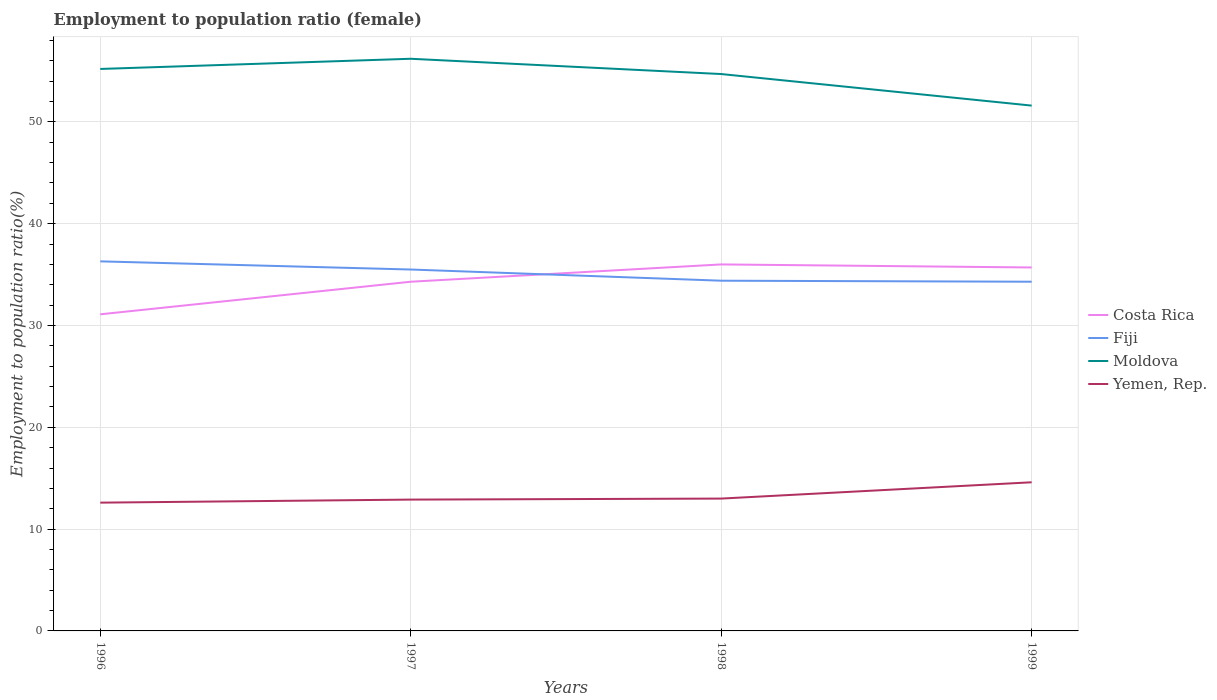How many different coloured lines are there?
Your answer should be compact. 4. Is the number of lines equal to the number of legend labels?
Ensure brevity in your answer.  Yes. Across all years, what is the maximum employment to population ratio in Moldova?
Your answer should be very brief. 51.6. What is the total employment to population ratio in Yemen, Rep. in the graph?
Keep it short and to the point. -1.7. Is the employment to population ratio in Yemen, Rep. strictly greater than the employment to population ratio in Costa Rica over the years?
Give a very brief answer. Yes. How many lines are there?
Offer a very short reply. 4. How many years are there in the graph?
Keep it short and to the point. 4. Does the graph contain grids?
Offer a terse response. Yes. What is the title of the graph?
Make the answer very short. Employment to population ratio (female). What is the label or title of the Y-axis?
Provide a succinct answer. Employment to population ratio(%). What is the Employment to population ratio(%) of Costa Rica in 1996?
Your answer should be very brief. 31.1. What is the Employment to population ratio(%) in Fiji in 1996?
Provide a succinct answer. 36.3. What is the Employment to population ratio(%) in Moldova in 1996?
Make the answer very short. 55.2. What is the Employment to population ratio(%) of Yemen, Rep. in 1996?
Ensure brevity in your answer.  12.6. What is the Employment to population ratio(%) in Costa Rica in 1997?
Ensure brevity in your answer.  34.3. What is the Employment to population ratio(%) in Fiji in 1997?
Your response must be concise. 35.5. What is the Employment to population ratio(%) in Moldova in 1997?
Keep it short and to the point. 56.2. What is the Employment to population ratio(%) in Yemen, Rep. in 1997?
Keep it short and to the point. 12.9. What is the Employment to population ratio(%) in Fiji in 1998?
Your response must be concise. 34.4. What is the Employment to population ratio(%) in Moldova in 1998?
Ensure brevity in your answer.  54.7. What is the Employment to population ratio(%) of Yemen, Rep. in 1998?
Give a very brief answer. 13. What is the Employment to population ratio(%) in Costa Rica in 1999?
Provide a short and direct response. 35.7. What is the Employment to population ratio(%) of Fiji in 1999?
Your answer should be compact. 34.3. What is the Employment to population ratio(%) of Moldova in 1999?
Provide a succinct answer. 51.6. What is the Employment to population ratio(%) of Yemen, Rep. in 1999?
Keep it short and to the point. 14.6. Across all years, what is the maximum Employment to population ratio(%) of Fiji?
Ensure brevity in your answer.  36.3. Across all years, what is the maximum Employment to population ratio(%) of Moldova?
Keep it short and to the point. 56.2. Across all years, what is the maximum Employment to population ratio(%) of Yemen, Rep.?
Offer a very short reply. 14.6. Across all years, what is the minimum Employment to population ratio(%) in Costa Rica?
Provide a succinct answer. 31.1. Across all years, what is the minimum Employment to population ratio(%) of Fiji?
Keep it short and to the point. 34.3. Across all years, what is the minimum Employment to population ratio(%) of Moldova?
Your answer should be compact. 51.6. Across all years, what is the minimum Employment to population ratio(%) of Yemen, Rep.?
Your answer should be compact. 12.6. What is the total Employment to population ratio(%) in Costa Rica in the graph?
Ensure brevity in your answer.  137.1. What is the total Employment to population ratio(%) of Fiji in the graph?
Your answer should be compact. 140.5. What is the total Employment to population ratio(%) in Moldova in the graph?
Give a very brief answer. 217.7. What is the total Employment to population ratio(%) in Yemen, Rep. in the graph?
Offer a terse response. 53.1. What is the difference between the Employment to population ratio(%) of Costa Rica in 1996 and that in 1997?
Provide a succinct answer. -3.2. What is the difference between the Employment to population ratio(%) in Fiji in 1996 and that in 1997?
Make the answer very short. 0.8. What is the difference between the Employment to population ratio(%) in Moldova in 1996 and that in 1997?
Your answer should be very brief. -1. What is the difference between the Employment to population ratio(%) in Fiji in 1996 and that in 1998?
Your answer should be very brief. 1.9. What is the difference between the Employment to population ratio(%) in Moldova in 1996 and that in 1998?
Provide a succinct answer. 0.5. What is the difference between the Employment to population ratio(%) of Yemen, Rep. in 1996 and that in 1998?
Your answer should be compact. -0.4. What is the difference between the Employment to population ratio(%) in Fiji in 1996 and that in 1999?
Make the answer very short. 2. What is the difference between the Employment to population ratio(%) of Fiji in 1997 and that in 1998?
Your answer should be very brief. 1.1. What is the difference between the Employment to population ratio(%) of Yemen, Rep. in 1997 and that in 1998?
Provide a succinct answer. -0.1. What is the difference between the Employment to population ratio(%) in Fiji in 1997 and that in 1999?
Ensure brevity in your answer.  1.2. What is the difference between the Employment to population ratio(%) in Moldova in 1997 and that in 1999?
Your answer should be compact. 4.6. What is the difference between the Employment to population ratio(%) in Costa Rica in 1998 and that in 1999?
Keep it short and to the point. 0.3. What is the difference between the Employment to population ratio(%) in Fiji in 1998 and that in 1999?
Provide a succinct answer. 0.1. What is the difference between the Employment to population ratio(%) in Moldova in 1998 and that in 1999?
Your answer should be compact. 3.1. What is the difference between the Employment to population ratio(%) in Costa Rica in 1996 and the Employment to population ratio(%) in Moldova in 1997?
Make the answer very short. -25.1. What is the difference between the Employment to population ratio(%) of Costa Rica in 1996 and the Employment to population ratio(%) of Yemen, Rep. in 1997?
Offer a very short reply. 18.2. What is the difference between the Employment to population ratio(%) in Fiji in 1996 and the Employment to population ratio(%) in Moldova in 1997?
Your response must be concise. -19.9. What is the difference between the Employment to population ratio(%) in Fiji in 1996 and the Employment to population ratio(%) in Yemen, Rep. in 1997?
Ensure brevity in your answer.  23.4. What is the difference between the Employment to population ratio(%) of Moldova in 1996 and the Employment to population ratio(%) of Yemen, Rep. in 1997?
Your answer should be compact. 42.3. What is the difference between the Employment to population ratio(%) in Costa Rica in 1996 and the Employment to population ratio(%) in Moldova in 1998?
Provide a succinct answer. -23.6. What is the difference between the Employment to population ratio(%) in Costa Rica in 1996 and the Employment to population ratio(%) in Yemen, Rep. in 1998?
Your answer should be very brief. 18.1. What is the difference between the Employment to population ratio(%) of Fiji in 1996 and the Employment to population ratio(%) of Moldova in 1998?
Offer a very short reply. -18.4. What is the difference between the Employment to population ratio(%) in Fiji in 1996 and the Employment to population ratio(%) in Yemen, Rep. in 1998?
Provide a succinct answer. 23.3. What is the difference between the Employment to population ratio(%) of Moldova in 1996 and the Employment to population ratio(%) of Yemen, Rep. in 1998?
Provide a short and direct response. 42.2. What is the difference between the Employment to population ratio(%) in Costa Rica in 1996 and the Employment to population ratio(%) in Fiji in 1999?
Provide a short and direct response. -3.2. What is the difference between the Employment to population ratio(%) in Costa Rica in 1996 and the Employment to population ratio(%) in Moldova in 1999?
Ensure brevity in your answer.  -20.5. What is the difference between the Employment to population ratio(%) in Fiji in 1996 and the Employment to population ratio(%) in Moldova in 1999?
Ensure brevity in your answer.  -15.3. What is the difference between the Employment to population ratio(%) of Fiji in 1996 and the Employment to population ratio(%) of Yemen, Rep. in 1999?
Ensure brevity in your answer.  21.7. What is the difference between the Employment to population ratio(%) in Moldova in 1996 and the Employment to population ratio(%) in Yemen, Rep. in 1999?
Ensure brevity in your answer.  40.6. What is the difference between the Employment to population ratio(%) of Costa Rica in 1997 and the Employment to population ratio(%) of Moldova in 1998?
Give a very brief answer. -20.4. What is the difference between the Employment to population ratio(%) of Costa Rica in 1997 and the Employment to population ratio(%) of Yemen, Rep. in 1998?
Provide a succinct answer. 21.3. What is the difference between the Employment to population ratio(%) in Fiji in 1997 and the Employment to population ratio(%) in Moldova in 1998?
Ensure brevity in your answer.  -19.2. What is the difference between the Employment to population ratio(%) of Moldova in 1997 and the Employment to population ratio(%) of Yemen, Rep. in 1998?
Offer a terse response. 43.2. What is the difference between the Employment to population ratio(%) of Costa Rica in 1997 and the Employment to population ratio(%) of Fiji in 1999?
Your answer should be very brief. 0. What is the difference between the Employment to population ratio(%) of Costa Rica in 1997 and the Employment to population ratio(%) of Moldova in 1999?
Your answer should be very brief. -17.3. What is the difference between the Employment to population ratio(%) of Costa Rica in 1997 and the Employment to population ratio(%) of Yemen, Rep. in 1999?
Your response must be concise. 19.7. What is the difference between the Employment to population ratio(%) in Fiji in 1997 and the Employment to population ratio(%) in Moldova in 1999?
Keep it short and to the point. -16.1. What is the difference between the Employment to population ratio(%) in Fiji in 1997 and the Employment to population ratio(%) in Yemen, Rep. in 1999?
Keep it short and to the point. 20.9. What is the difference between the Employment to population ratio(%) of Moldova in 1997 and the Employment to population ratio(%) of Yemen, Rep. in 1999?
Your response must be concise. 41.6. What is the difference between the Employment to population ratio(%) in Costa Rica in 1998 and the Employment to population ratio(%) in Moldova in 1999?
Your answer should be very brief. -15.6. What is the difference between the Employment to population ratio(%) of Costa Rica in 1998 and the Employment to population ratio(%) of Yemen, Rep. in 1999?
Your answer should be very brief. 21.4. What is the difference between the Employment to population ratio(%) of Fiji in 1998 and the Employment to population ratio(%) of Moldova in 1999?
Your answer should be compact. -17.2. What is the difference between the Employment to population ratio(%) in Fiji in 1998 and the Employment to population ratio(%) in Yemen, Rep. in 1999?
Make the answer very short. 19.8. What is the difference between the Employment to population ratio(%) in Moldova in 1998 and the Employment to population ratio(%) in Yemen, Rep. in 1999?
Your response must be concise. 40.1. What is the average Employment to population ratio(%) of Costa Rica per year?
Your answer should be very brief. 34.27. What is the average Employment to population ratio(%) of Fiji per year?
Make the answer very short. 35.12. What is the average Employment to population ratio(%) in Moldova per year?
Offer a very short reply. 54.42. What is the average Employment to population ratio(%) of Yemen, Rep. per year?
Make the answer very short. 13.28. In the year 1996, what is the difference between the Employment to population ratio(%) of Costa Rica and Employment to population ratio(%) of Fiji?
Make the answer very short. -5.2. In the year 1996, what is the difference between the Employment to population ratio(%) in Costa Rica and Employment to population ratio(%) in Moldova?
Provide a short and direct response. -24.1. In the year 1996, what is the difference between the Employment to population ratio(%) of Fiji and Employment to population ratio(%) of Moldova?
Offer a very short reply. -18.9. In the year 1996, what is the difference between the Employment to population ratio(%) in Fiji and Employment to population ratio(%) in Yemen, Rep.?
Provide a short and direct response. 23.7. In the year 1996, what is the difference between the Employment to population ratio(%) of Moldova and Employment to population ratio(%) of Yemen, Rep.?
Offer a very short reply. 42.6. In the year 1997, what is the difference between the Employment to population ratio(%) in Costa Rica and Employment to population ratio(%) in Moldova?
Offer a terse response. -21.9. In the year 1997, what is the difference between the Employment to population ratio(%) of Costa Rica and Employment to population ratio(%) of Yemen, Rep.?
Your response must be concise. 21.4. In the year 1997, what is the difference between the Employment to population ratio(%) in Fiji and Employment to population ratio(%) in Moldova?
Provide a succinct answer. -20.7. In the year 1997, what is the difference between the Employment to population ratio(%) in Fiji and Employment to population ratio(%) in Yemen, Rep.?
Give a very brief answer. 22.6. In the year 1997, what is the difference between the Employment to population ratio(%) in Moldova and Employment to population ratio(%) in Yemen, Rep.?
Keep it short and to the point. 43.3. In the year 1998, what is the difference between the Employment to population ratio(%) of Costa Rica and Employment to population ratio(%) of Moldova?
Keep it short and to the point. -18.7. In the year 1998, what is the difference between the Employment to population ratio(%) in Fiji and Employment to population ratio(%) in Moldova?
Make the answer very short. -20.3. In the year 1998, what is the difference between the Employment to population ratio(%) in Fiji and Employment to population ratio(%) in Yemen, Rep.?
Your response must be concise. 21.4. In the year 1998, what is the difference between the Employment to population ratio(%) in Moldova and Employment to population ratio(%) in Yemen, Rep.?
Keep it short and to the point. 41.7. In the year 1999, what is the difference between the Employment to population ratio(%) in Costa Rica and Employment to population ratio(%) in Fiji?
Give a very brief answer. 1.4. In the year 1999, what is the difference between the Employment to population ratio(%) of Costa Rica and Employment to population ratio(%) of Moldova?
Your response must be concise. -15.9. In the year 1999, what is the difference between the Employment to population ratio(%) in Costa Rica and Employment to population ratio(%) in Yemen, Rep.?
Your answer should be very brief. 21.1. In the year 1999, what is the difference between the Employment to population ratio(%) of Fiji and Employment to population ratio(%) of Moldova?
Offer a terse response. -17.3. What is the ratio of the Employment to population ratio(%) of Costa Rica in 1996 to that in 1997?
Ensure brevity in your answer.  0.91. What is the ratio of the Employment to population ratio(%) of Fiji in 1996 to that in 1997?
Provide a short and direct response. 1.02. What is the ratio of the Employment to population ratio(%) in Moldova in 1996 to that in 1997?
Your answer should be compact. 0.98. What is the ratio of the Employment to population ratio(%) in Yemen, Rep. in 1996 to that in 1997?
Keep it short and to the point. 0.98. What is the ratio of the Employment to population ratio(%) in Costa Rica in 1996 to that in 1998?
Your response must be concise. 0.86. What is the ratio of the Employment to population ratio(%) of Fiji in 1996 to that in 1998?
Make the answer very short. 1.06. What is the ratio of the Employment to population ratio(%) of Moldova in 1996 to that in 1998?
Your answer should be very brief. 1.01. What is the ratio of the Employment to population ratio(%) in Yemen, Rep. in 1996 to that in 1998?
Provide a succinct answer. 0.97. What is the ratio of the Employment to population ratio(%) in Costa Rica in 1996 to that in 1999?
Your answer should be compact. 0.87. What is the ratio of the Employment to population ratio(%) of Fiji in 1996 to that in 1999?
Your response must be concise. 1.06. What is the ratio of the Employment to population ratio(%) of Moldova in 1996 to that in 1999?
Your answer should be very brief. 1.07. What is the ratio of the Employment to population ratio(%) of Yemen, Rep. in 1996 to that in 1999?
Give a very brief answer. 0.86. What is the ratio of the Employment to population ratio(%) of Costa Rica in 1997 to that in 1998?
Make the answer very short. 0.95. What is the ratio of the Employment to population ratio(%) in Fiji in 1997 to that in 1998?
Your answer should be compact. 1.03. What is the ratio of the Employment to population ratio(%) in Moldova in 1997 to that in 1998?
Your answer should be compact. 1.03. What is the ratio of the Employment to population ratio(%) of Costa Rica in 1997 to that in 1999?
Provide a succinct answer. 0.96. What is the ratio of the Employment to population ratio(%) in Fiji in 1997 to that in 1999?
Provide a succinct answer. 1.03. What is the ratio of the Employment to population ratio(%) of Moldova in 1997 to that in 1999?
Offer a very short reply. 1.09. What is the ratio of the Employment to population ratio(%) in Yemen, Rep. in 1997 to that in 1999?
Your answer should be compact. 0.88. What is the ratio of the Employment to population ratio(%) in Costa Rica in 1998 to that in 1999?
Make the answer very short. 1.01. What is the ratio of the Employment to population ratio(%) in Fiji in 1998 to that in 1999?
Give a very brief answer. 1. What is the ratio of the Employment to population ratio(%) in Moldova in 1998 to that in 1999?
Ensure brevity in your answer.  1.06. What is the ratio of the Employment to population ratio(%) in Yemen, Rep. in 1998 to that in 1999?
Your answer should be compact. 0.89. What is the difference between the highest and the second highest Employment to population ratio(%) of Costa Rica?
Ensure brevity in your answer.  0.3. What is the difference between the highest and the second highest Employment to population ratio(%) of Fiji?
Provide a succinct answer. 0.8. What is the difference between the highest and the lowest Employment to population ratio(%) of Moldova?
Make the answer very short. 4.6. What is the difference between the highest and the lowest Employment to population ratio(%) in Yemen, Rep.?
Give a very brief answer. 2. 